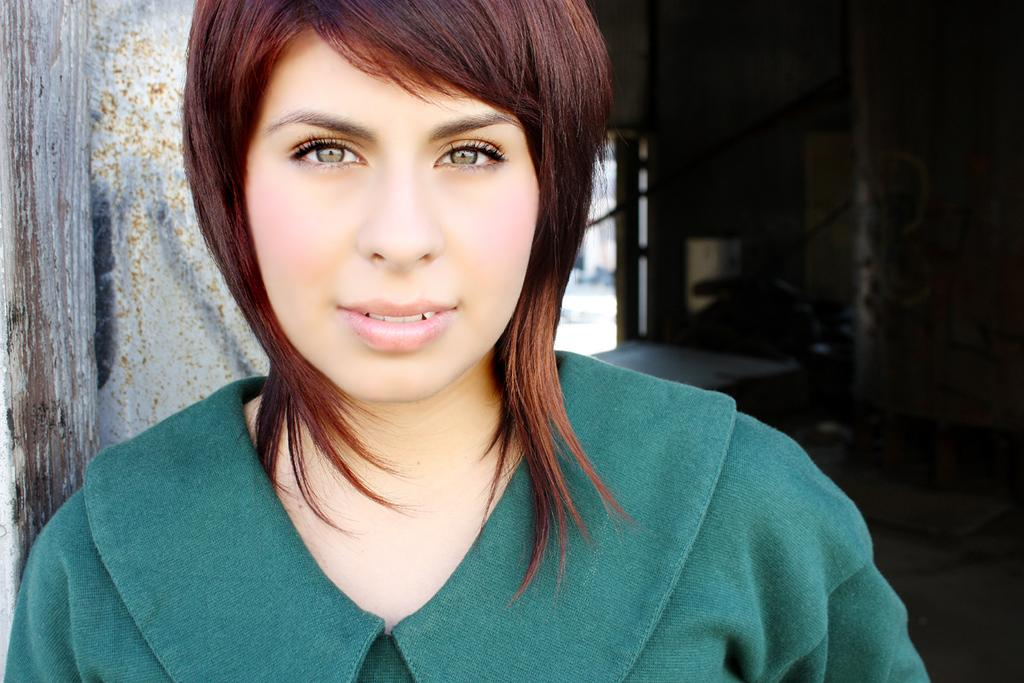Who is present in the image? There is a woman in the image. What can be seen in the background of the image? There appears to be a house in the background of the image. What direction is the pump facing in the image? There is no pump present in the image. What type of paste is being used by the woman in the image? There is no paste visible in the image, and the woman's actions are not described. 